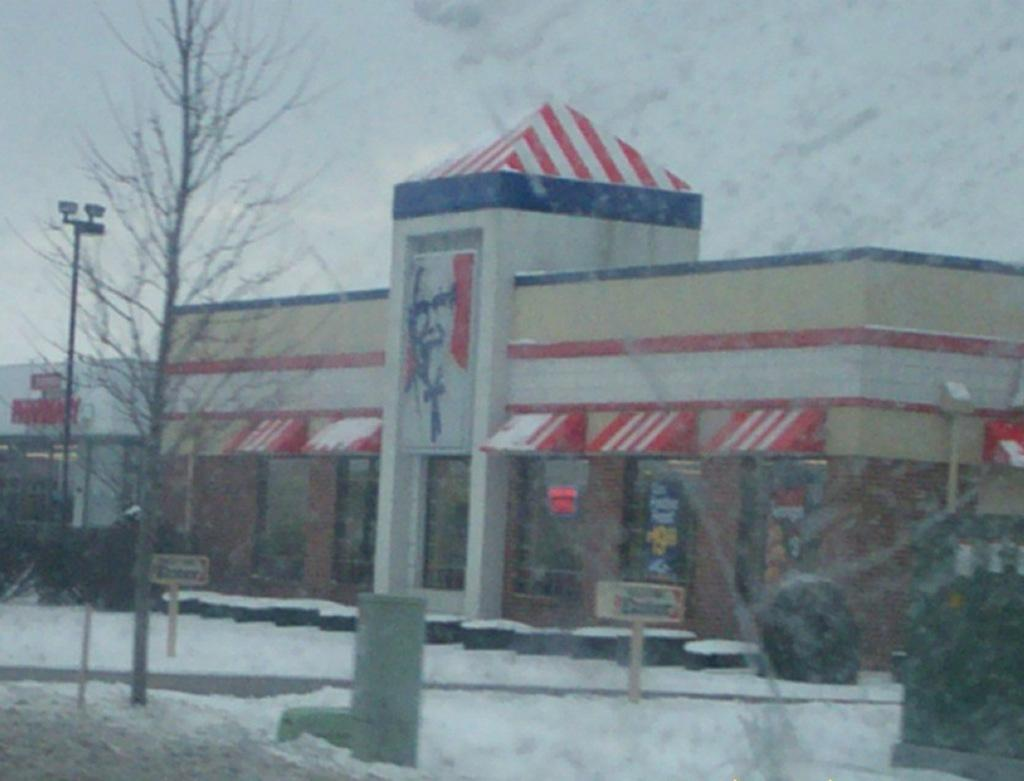What type of structures can be seen in the image? There are buildings in the image. What is the weather condition in the image? There is snow visible in the image, indicating a cold or wintery environment. What are the name boards used for in the image? Name boards are present in the image, likely to identify or label specific buildings or locations. What type of vegetation is present in the image? There are trees in the image. What utility infrastructure can be seen in the image? An electric pole is visible in the image. Can you describe any other objects in the image? There are other objects in the image, but their specific details are not mentioned in the provided facts. What is visible in the background of the image? The sky is visible in the background of the image. What type of hat is the maid wearing in the image? There is no maid or hat present in the image. What type of iron is being used to press clothes in the image? There is no iron or ironing activity depicted in the image. 